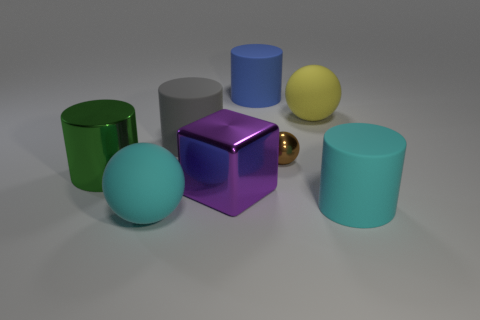Add 2 small red metal cylinders. How many objects exist? 10 Subtract all rubber cylinders. How many cylinders are left? 1 Subtract all yellow spheres. How many spheres are left? 2 Add 3 large cyan spheres. How many large cyan spheres are left? 4 Add 6 cyan objects. How many cyan objects exist? 8 Subtract 0 yellow cubes. How many objects are left? 8 Subtract all spheres. How many objects are left? 5 Subtract 3 cylinders. How many cylinders are left? 1 Subtract all cyan spheres. Subtract all green cylinders. How many spheres are left? 2 Subtract all brown balls. Subtract all small spheres. How many objects are left? 6 